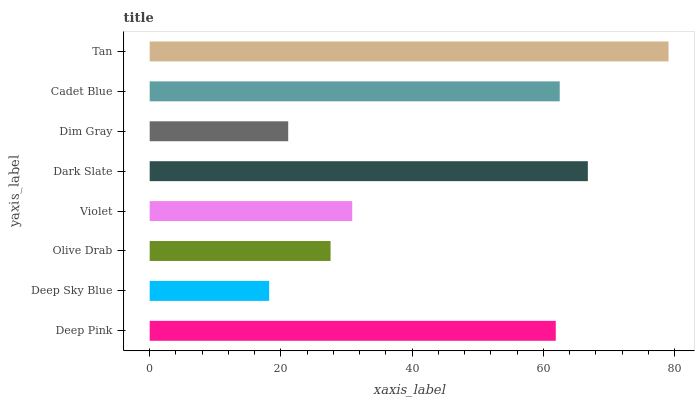Is Deep Sky Blue the minimum?
Answer yes or no. Yes. Is Tan the maximum?
Answer yes or no. Yes. Is Olive Drab the minimum?
Answer yes or no. No. Is Olive Drab the maximum?
Answer yes or no. No. Is Olive Drab greater than Deep Sky Blue?
Answer yes or no. Yes. Is Deep Sky Blue less than Olive Drab?
Answer yes or no. Yes. Is Deep Sky Blue greater than Olive Drab?
Answer yes or no. No. Is Olive Drab less than Deep Sky Blue?
Answer yes or no. No. Is Deep Pink the high median?
Answer yes or no. Yes. Is Violet the low median?
Answer yes or no. Yes. Is Cadet Blue the high median?
Answer yes or no. No. Is Olive Drab the low median?
Answer yes or no. No. 